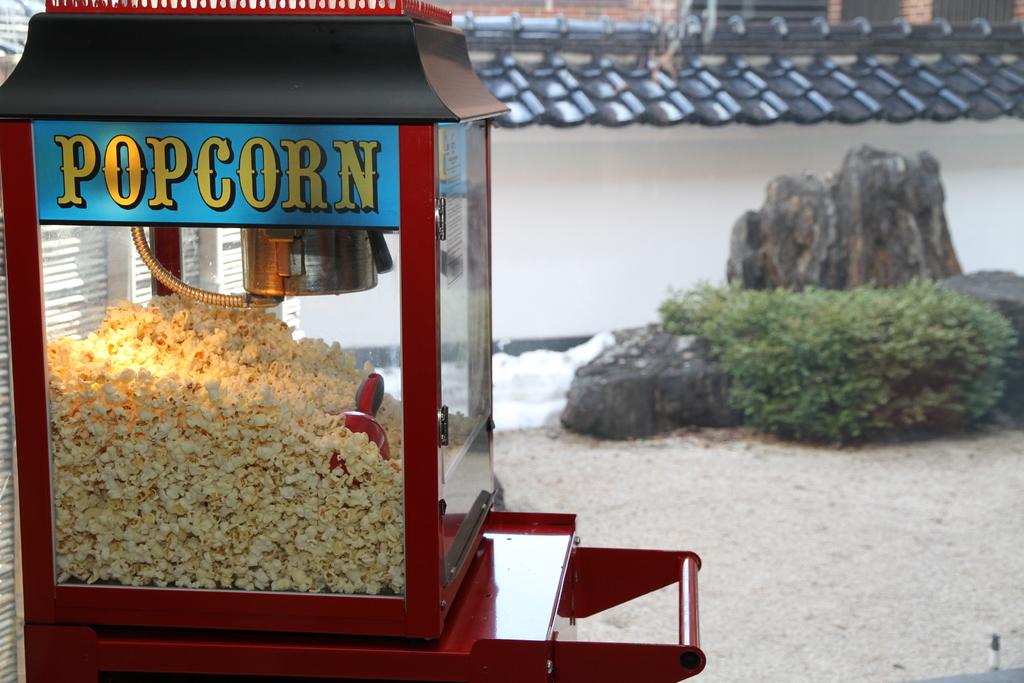What is inside the glass?
Your answer should be compact. Popcorn. 